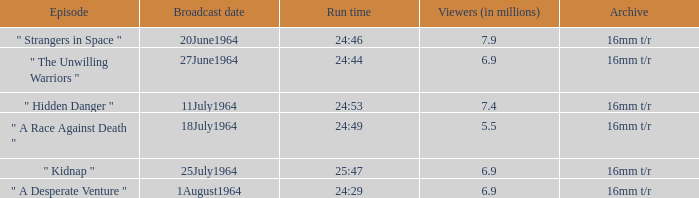Which episode was broadcasted on 11 july 1964? " Hidden Danger ". 